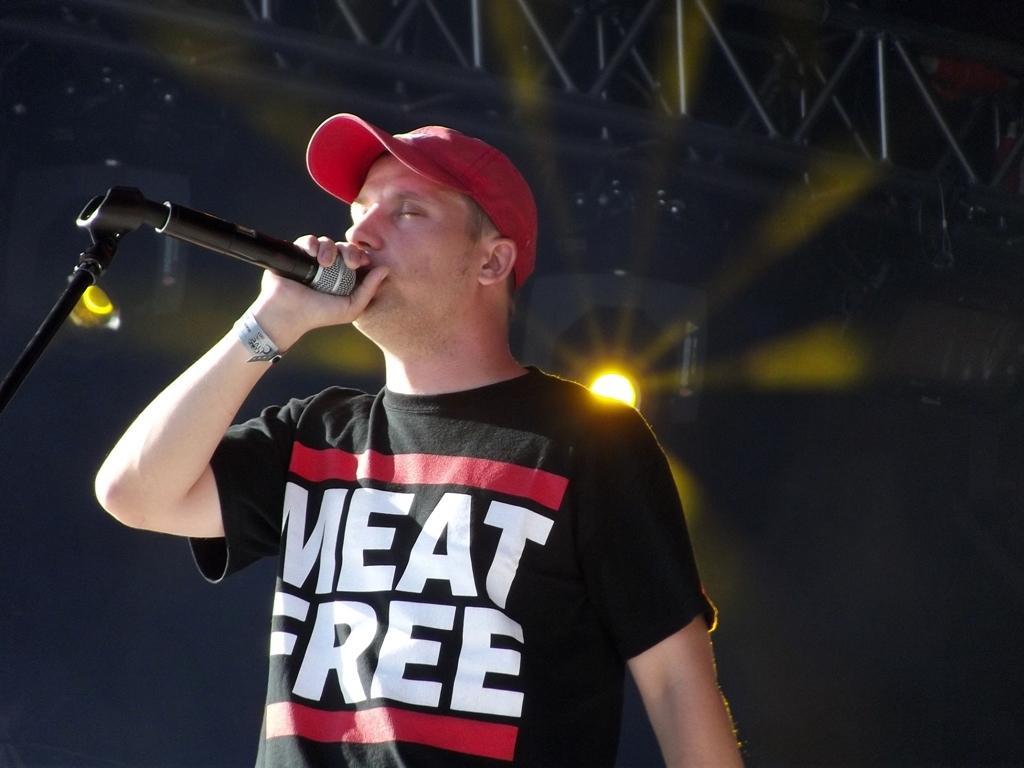How would you summarize this image in a sentence or two? In this image I can see a man wearing black color t-shirt and holding a mike in his hand and also I can see a red color cap on his head. In the background there is a light. 